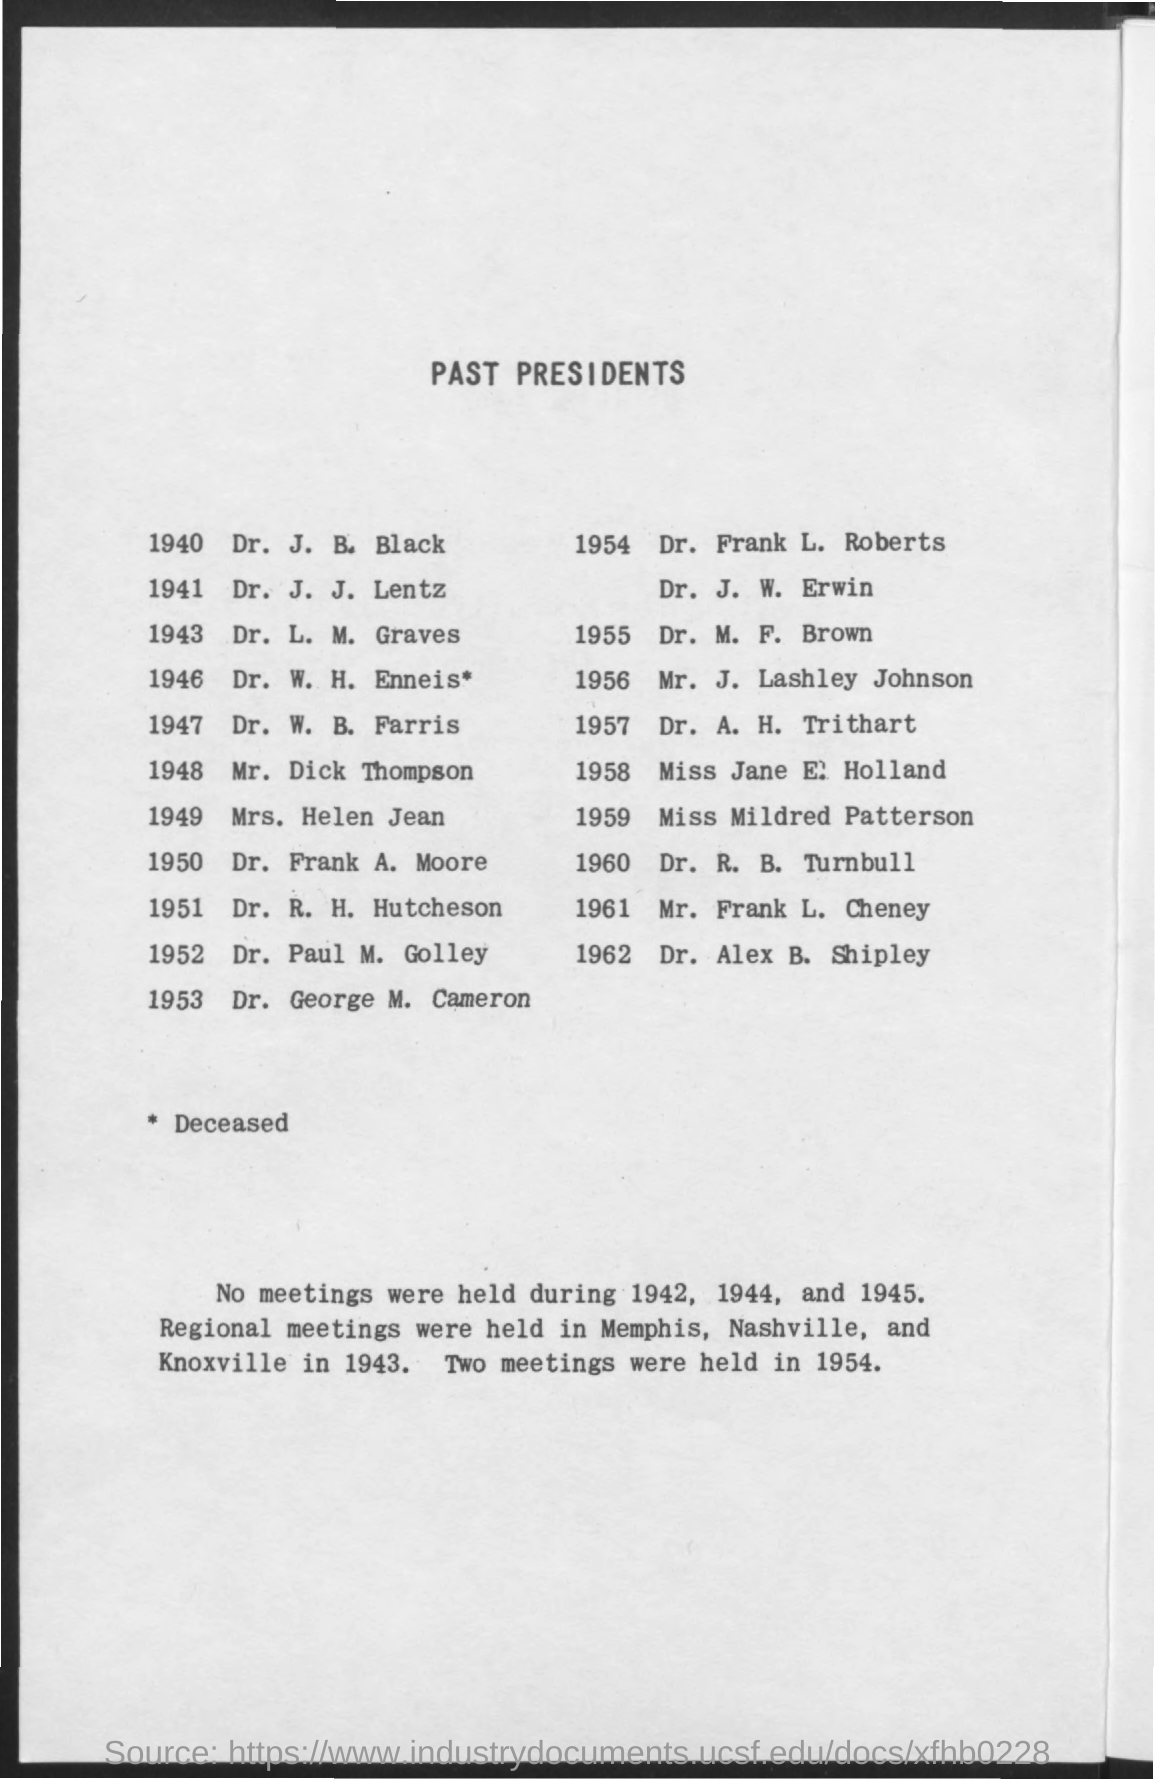Give some essential details in this illustration. The title of the document is 'List of Past Presidents.' Two meetings were held in the year 1954. 